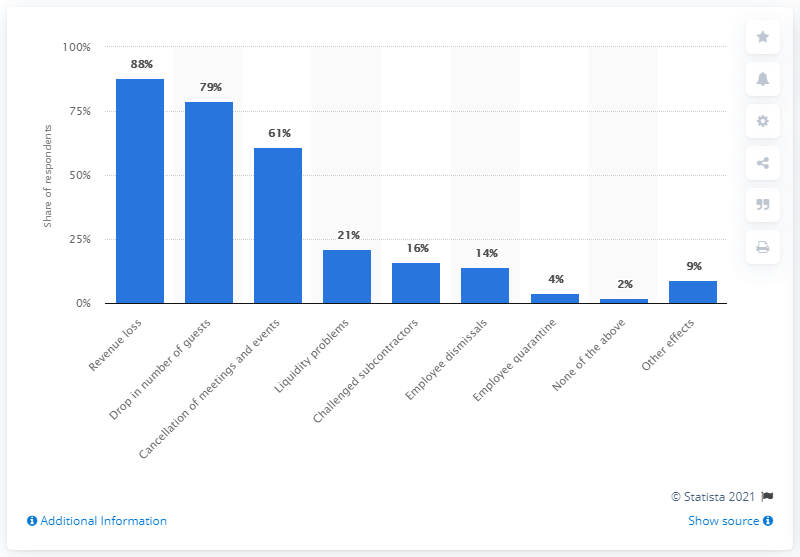Point out several critical features in this image. According to a survey on the impact of the coronavirus on the tourism industry in Denmark, 88% of businesses reported experiencing a revenue loss. 